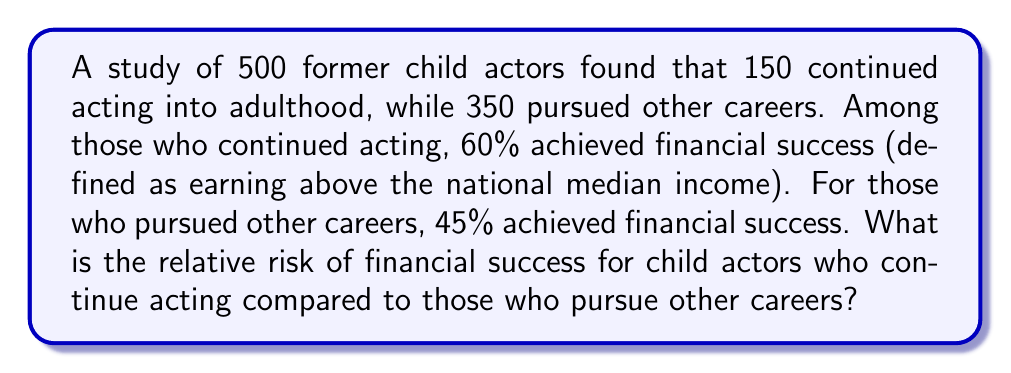Could you help me with this problem? To calculate the relative risk, we need to follow these steps:

1. Calculate the risk of financial success for those who continued acting:
   $$P(\text{success | continued acting}) = \frac{60}{100} = 0.60$$

2. Calculate the risk of financial success for those who pursued other careers:
   $$P(\text{success | other careers}) = \frac{45}{100} = 0.45$$

3. Calculate the relative risk by dividing the risk for those who continued acting by the risk for those who pursued other careers:
   $$\text{Relative Risk} = \frac{P(\text{success | continued acting})}{P(\text{success | other careers})} = \frac{0.60}{0.45} = \frac{4}{3} \approx 1.33$$

The relative risk is approximately 1.33, which means that child actors who continue acting into adulthood are 1.33 times more likely to achieve financial success compared to those who pursue other careers.
Answer: 1.33 